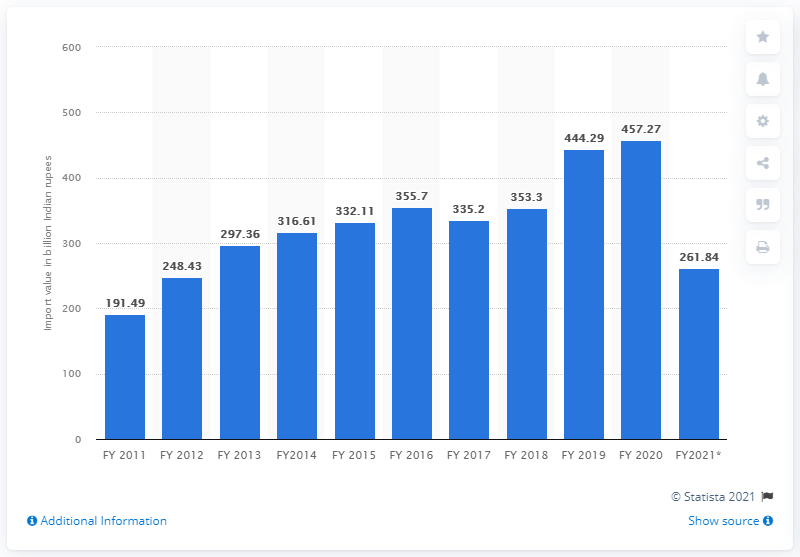Mention a couple of crucial points in this snapshot. In the financial year 2021, India imported a total of 261.84 Indian rupees. In the fiscal year 2020, India imported a total of 457.27 million Indian rupees worth of medicinal and pharmaceutical products. 